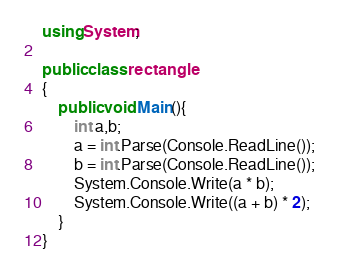Convert code to text. <code><loc_0><loc_0><loc_500><loc_500><_C#_>using System;

public class rectangle
{
    public void Main(){
        int a,b;
        a = int.Parse(Console.ReadLine());
        b = int.Parse(Console.ReadLine());
        System.Console.Write(a * b);
        System.Console.Write((a + b) * 2);
    }
}</code> 